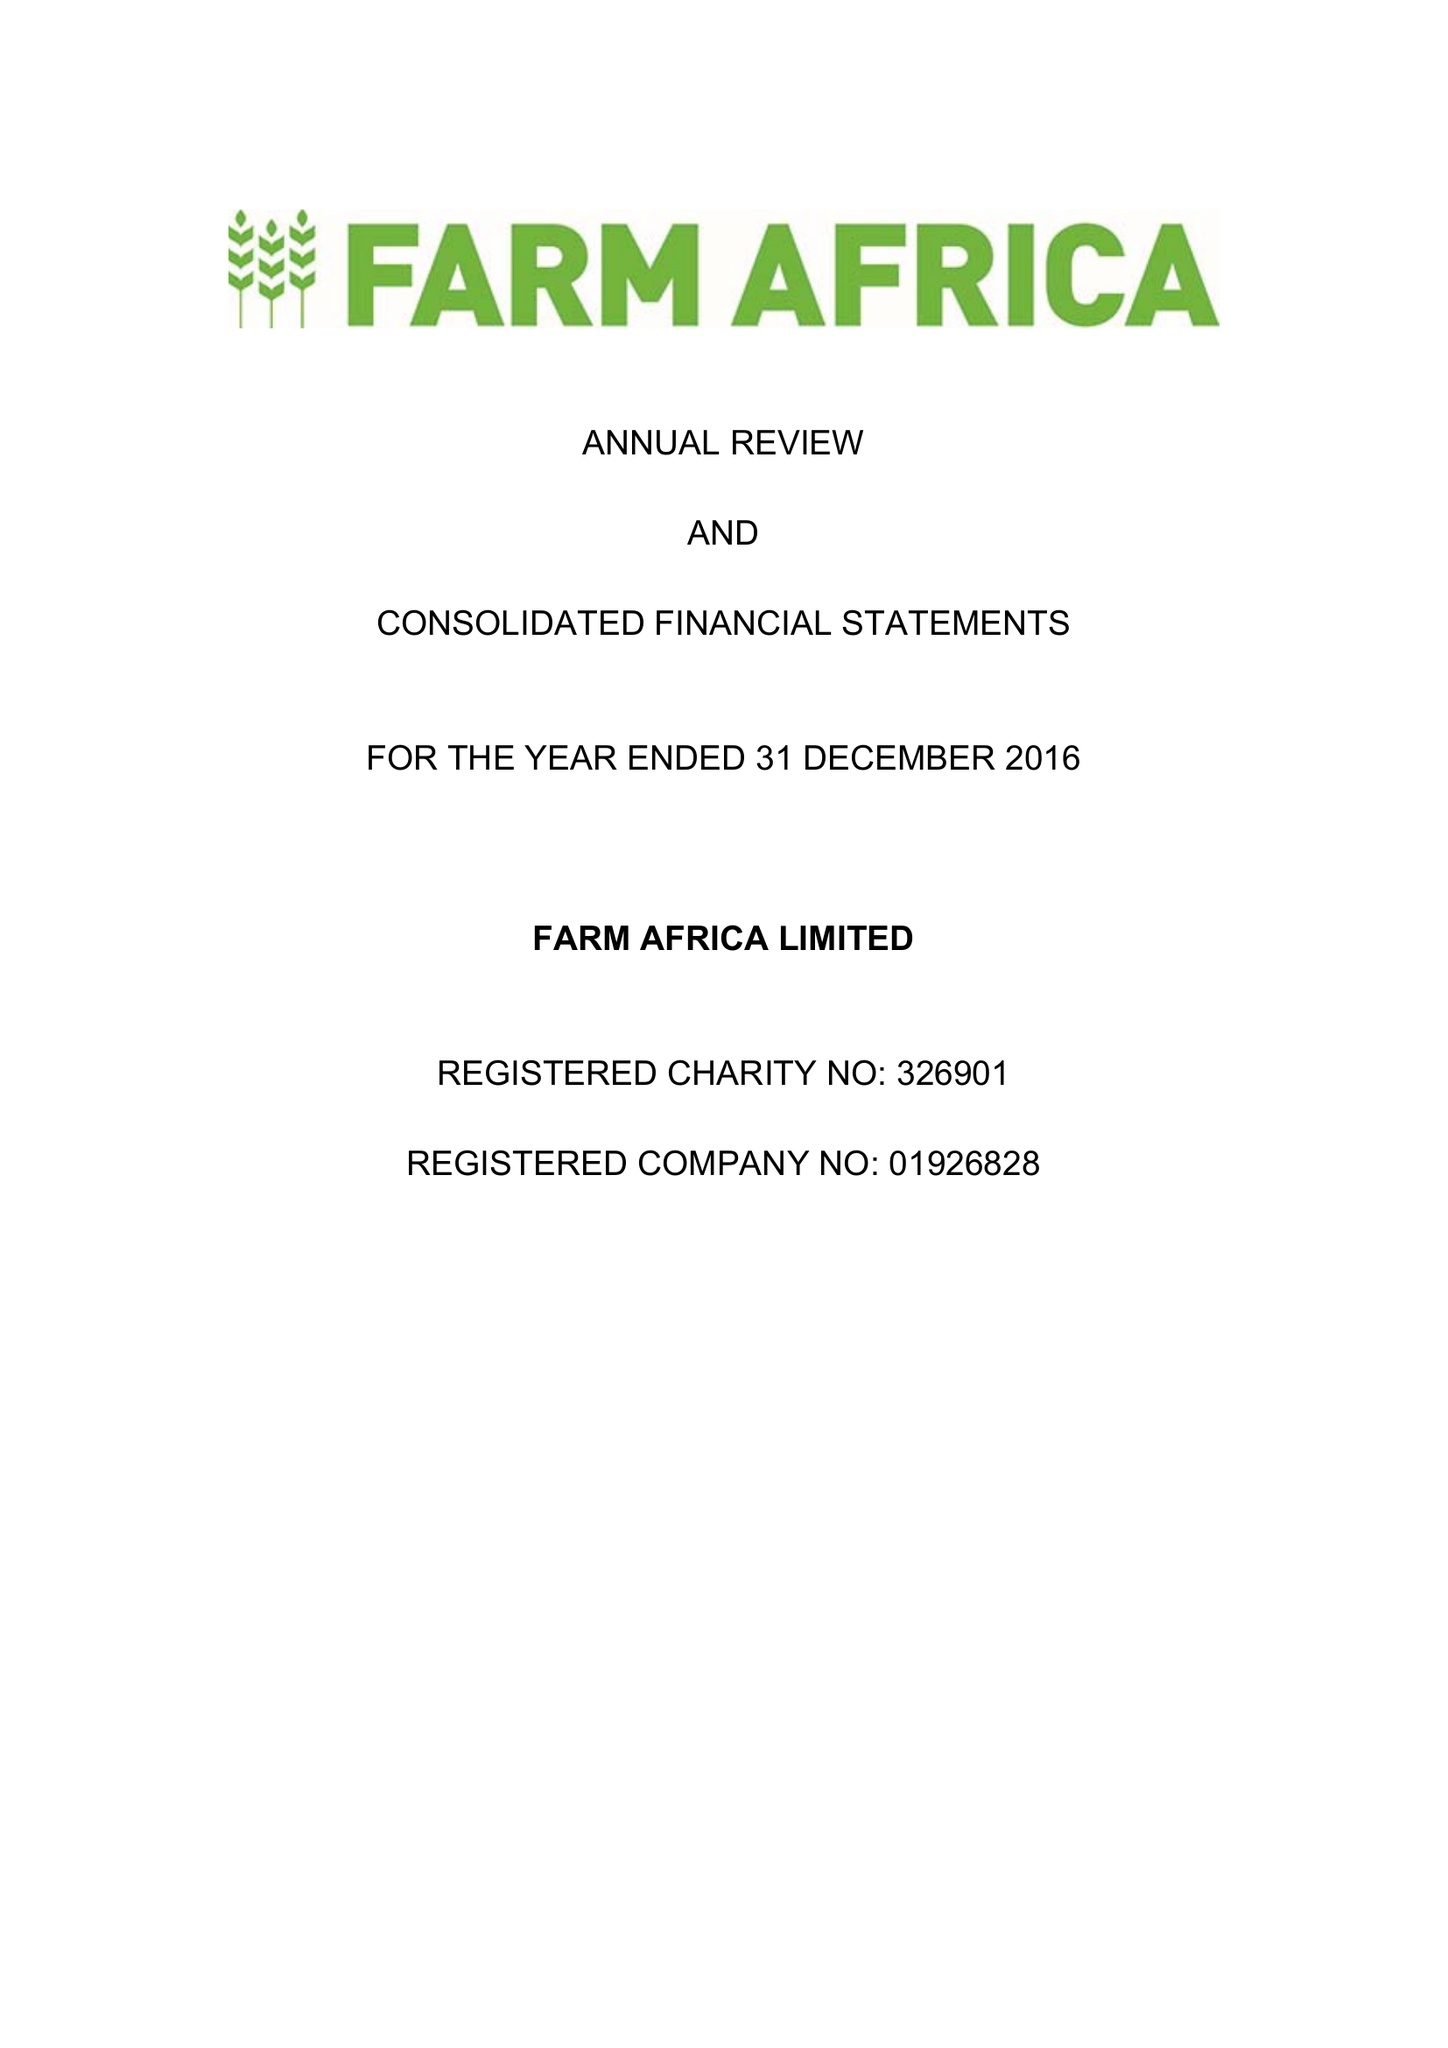What is the value for the report_date?
Answer the question using a single word or phrase. 2016-12-31 